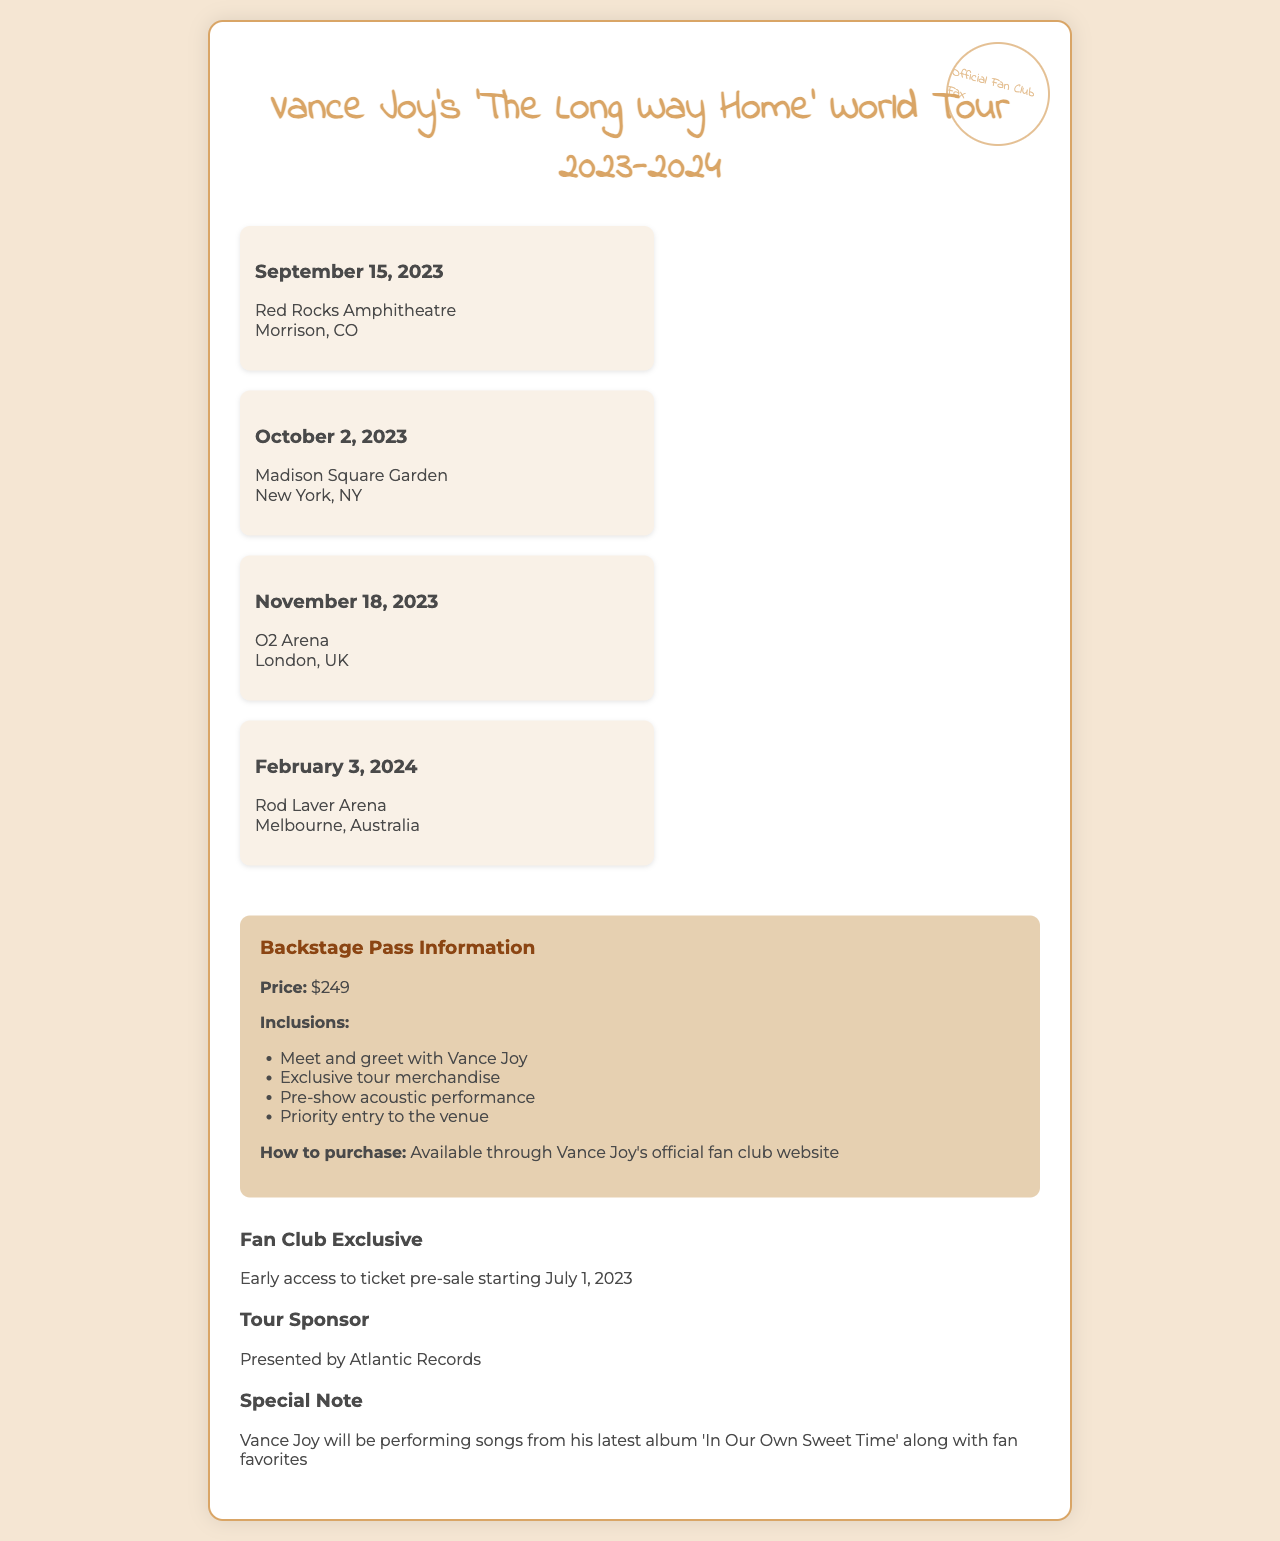what is the title of the tour? The title of the tour is explicitly stated in the document header as 'The Long Way Home' World Tour 2023-2024.
Answer: 'The Long Way Home' World Tour 2023-2024 when is the concert at Madison Square Garden? The document specifies that the concert at Madison Square Garden is scheduled for October 2, 2023.
Answer: October 2, 2023 what is the venue for the concert on February 3, 2024? The document lists Rod Laver Arena as the venue for the concert on February 3, 2024.
Answer: Rod Laver Arena how much is a backstage pass? The document indicates that the price for a backstage pass is $249.
Answer: $249 what do you receive with a backstage pass? The document outlines several inclusions, such as a meet and greet with Vance Joy and exclusive tour merchandise, among others.
Answer: Meet and greet with Vance Joy who is the tour sponsor? The document indicates that the tour is presented by Atlantic Records, which is the tour sponsor.
Answer: Atlantic Records what is the special note regarding the performance? The special note mentions that Vance Joy will perform songs from his latest album along with fan favorites.
Answer: 'In Our Own Sweet Time' along with fan favorites when does the fan club pre-sale start? According to the document, the early access to ticket pre-sale for the fan club starts on July 1, 2023.
Answer: July 1, 2023 